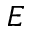<formula> <loc_0><loc_0><loc_500><loc_500>E</formula> 